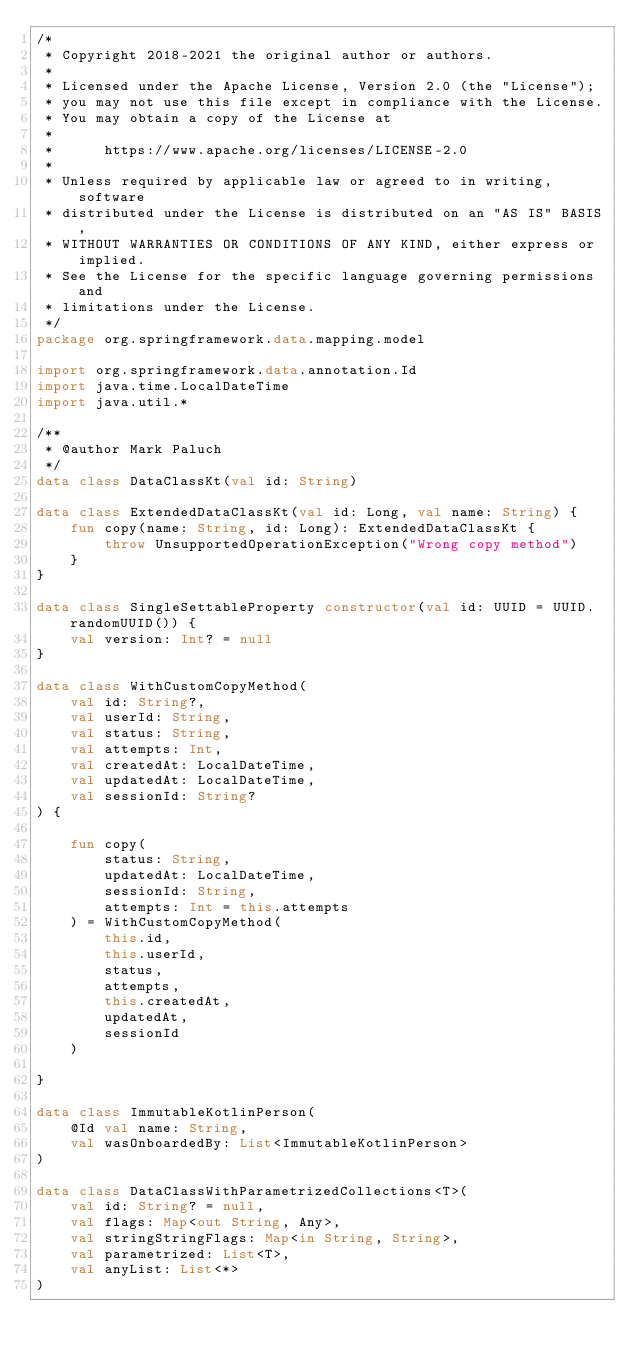<code> <loc_0><loc_0><loc_500><loc_500><_Kotlin_>/*
 * Copyright 2018-2021 the original author or authors.
 *
 * Licensed under the Apache License, Version 2.0 (the "License");
 * you may not use this file except in compliance with the License.
 * You may obtain a copy of the License at
 *
 *      https://www.apache.org/licenses/LICENSE-2.0
 *
 * Unless required by applicable law or agreed to in writing, software
 * distributed under the License is distributed on an "AS IS" BASIS,
 * WITHOUT WARRANTIES OR CONDITIONS OF ANY KIND, either express or implied.
 * See the License for the specific language governing permissions and
 * limitations under the License.
 */
package org.springframework.data.mapping.model

import org.springframework.data.annotation.Id
import java.time.LocalDateTime
import java.util.*

/**
 * @author Mark Paluch
 */
data class DataClassKt(val id: String)

data class ExtendedDataClassKt(val id: Long, val name: String) {
	fun copy(name: String, id: Long): ExtendedDataClassKt {
		throw UnsupportedOperationException("Wrong copy method")
	}
}

data class SingleSettableProperty constructor(val id: UUID = UUID.randomUUID()) {
	val version: Int? = null
}

data class WithCustomCopyMethod(
	val id: String?,
	val userId: String,
	val status: String,
	val attempts: Int,
	val createdAt: LocalDateTime,
	val updatedAt: LocalDateTime,
	val sessionId: String?
) {

	fun copy(
		status: String,
		updatedAt: LocalDateTime,
		sessionId: String,
		attempts: Int = this.attempts
	) = WithCustomCopyMethod(
		this.id,
		this.userId,
		status,
		attempts,
		this.createdAt,
		updatedAt,
		sessionId
	)

}

data class ImmutableKotlinPerson(
	@Id val name: String,
	val wasOnboardedBy: List<ImmutableKotlinPerson>
)

data class DataClassWithParametrizedCollections<T>(
	val id: String? = null,
	val flags: Map<out String, Any>,
	val stringStringFlags: Map<in String, String>,
	val parametrized: List<T>,
	val anyList: List<*>
)

</code> 